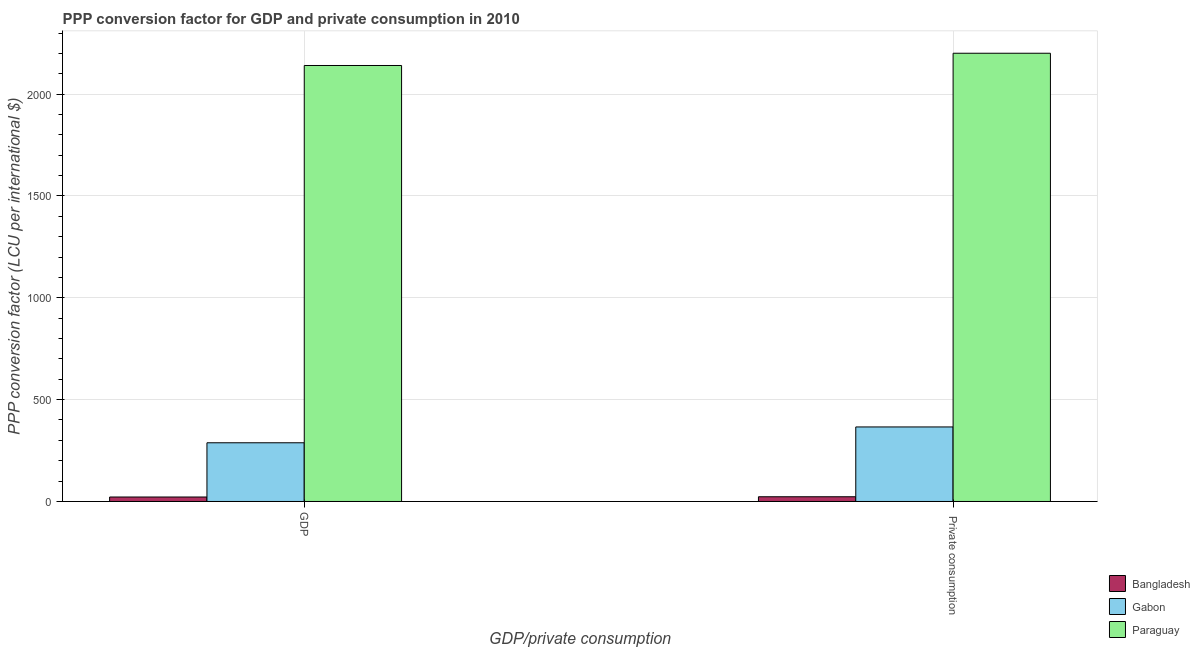How many different coloured bars are there?
Offer a terse response. 3. Are the number of bars on each tick of the X-axis equal?
Offer a terse response. Yes. How many bars are there on the 2nd tick from the left?
Give a very brief answer. 3. What is the label of the 2nd group of bars from the left?
Your answer should be compact.  Private consumption. What is the ppp conversion factor for private consumption in Bangladesh?
Make the answer very short. 23.15. Across all countries, what is the maximum ppp conversion factor for private consumption?
Give a very brief answer. 2200.69. Across all countries, what is the minimum ppp conversion factor for gdp?
Your answer should be compact. 21.9. In which country was the ppp conversion factor for private consumption maximum?
Offer a terse response. Paraguay. What is the total ppp conversion factor for gdp in the graph?
Provide a short and direct response. 2450.59. What is the difference between the ppp conversion factor for private consumption in Gabon and that in Bangladesh?
Keep it short and to the point. 342.76. What is the difference between the ppp conversion factor for gdp in Bangladesh and the ppp conversion factor for private consumption in Paraguay?
Give a very brief answer. -2178.79. What is the average ppp conversion factor for gdp per country?
Give a very brief answer. 816.86. What is the difference between the ppp conversion factor for private consumption and ppp conversion factor for gdp in Gabon?
Offer a very short reply. 77.73. What is the ratio of the ppp conversion factor for private consumption in Gabon to that in Paraguay?
Your response must be concise. 0.17. Is the ppp conversion factor for private consumption in Gabon less than that in Paraguay?
Provide a succinct answer. Yes. What does the 2nd bar from the left in  Private consumption represents?
Provide a short and direct response. Gabon. What does the 1st bar from the right in GDP represents?
Make the answer very short. Paraguay. How many countries are there in the graph?
Your answer should be very brief. 3. What is the difference between two consecutive major ticks on the Y-axis?
Your answer should be compact. 500. Does the graph contain grids?
Keep it short and to the point. Yes. Where does the legend appear in the graph?
Make the answer very short. Bottom right. How many legend labels are there?
Your answer should be very brief. 3. How are the legend labels stacked?
Offer a very short reply. Vertical. What is the title of the graph?
Your answer should be compact. PPP conversion factor for GDP and private consumption in 2010. Does "Albania" appear as one of the legend labels in the graph?
Offer a terse response. No. What is the label or title of the X-axis?
Offer a terse response. GDP/private consumption. What is the label or title of the Y-axis?
Ensure brevity in your answer.  PPP conversion factor (LCU per international $). What is the PPP conversion factor (LCU per international $) of Bangladesh in GDP?
Your answer should be compact. 21.9. What is the PPP conversion factor (LCU per international $) of Gabon in GDP?
Offer a terse response. 288.18. What is the PPP conversion factor (LCU per international $) in Paraguay in GDP?
Make the answer very short. 2140.51. What is the PPP conversion factor (LCU per international $) of Bangladesh in  Private consumption?
Make the answer very short. 23.15. What is the PPP conversion factor (LCU per international $) in Gabon in  Private consumption?
Ensure brevity in your answer.  365.91. What is the PPP conversion factor (LCU per international $) in Paraguay in  Private consumption?
Give a very brief answer. 2200.69. Across all GDP/private consumption, what is the maximum PPP conversion factor (LCU per international $) of Bangladesh?
Your answer should be compact. 23.15. Across all GDP/private consumption, what is the maximum PPP conversion factor (LCU per international $) in Gabon?
Give a very brief answer. 365.91. Across all GDP/private consumption, what is the maximum PPP conversion factor (LCU per international $) in Paraguay?
Keep it short and to the point. 2200.69. Across all GDP/private consumption, what is the minimum PPP conversion factor (LCU per international $) in Bangladesh?
Provide a short and direct response. 21.9. Across all GDP/private consumption, what is the minimum PPP conversion factor (LCU per international $) of Gabon?
Your response must be concise. 288.18. Across all GDP/private consumption, what is the minimum PPP conversion factor (LCU per international $) of Paraguay?
Offer a very short reply. 2140.51. What is the total PPP conversion factor (LCU per international $) of Bangladesh in the graph?
Provide a short and direct response. 45.06. What is the total PPP conversion factor (LCU per international $) of Gabon in the graph?
Provide a succinct answer. 654.09. What is the total PPP conversion factor (LCU per international $) in Paraguay in the graph?
Provide a short and direct response. 4341.2. What is the difference between the PPP conversion factor (LCU per international $) of Bangladesh in GDP and that in  Private consumption?
Offer a terse response. -1.25. What is the difference between the PPP conversion factor (LCU per international $) in Gabon in GDP and that in  Private consumption?
Provide a short and direct response. -77.73. What is the difference between the PPP conversion factor (LCU per international $) in Paraguay in GDP and that in  Private consumption?
Provide a succinct answer. -60.18. What is the difference between the PPP conversion factor (LCU per international $) in Bangladesh in GDP and the PPP conversion factor (LCU per international $) in Gabon in  Private consumption?
Provide a short and direct response. -344.01. What is the difference between the PPP conversion factor (LCU per international $) in Bangladesh in GDP and the PPP conversion factor (LCU per international $) in Paraguay in  Private consumption?
Provide a short and direct response. -2178.79. What is the difference between the PPP conversion factor (LCU per international $) in Gabon in GDP and the PPP conversion factor (LCU per international $) in Paraguay in  Private consumption?
Give a very brief answer. -1912.51. What is the average PPP conversion factor (LCU per international $) in Bangladesh per GDP/private consumption?
Keep it short and to the point. 22.53. What is the average PPP conversion factor (LCU per international $) in Gabon per GDP/private consumption?
Offer a terse response. 327.05. What is the average PPP conversion factor (LCU per international $) of Paraguay per GDP/private consumption?
Offer a very short reply. 2170.6. What is the difference between the PPP conversion factor (LCU per international $) in Bangladesh and PPP conversion factor (LCU per international $) in Gabon in GDP?
Provide a short and direct response. -266.28. What is the difference between the PPP conversion factor (LCU per international $) of Bangladesh and PPP conversion factor (LCU per international $) of Paraguay in GDP?
Offer a terse response. -2118.61. What is the difference between the PPP conversion factor (LCU per international $) in Gabon and PPP conversion factor (LCU per international $) in Paraguay in GDP?
Keep it short and to the point. -1852.33. What is the difference between the PPP conversion factor (LCU per international $) in Bangladesh and PPP conversion factor (LCU per international $) in Gabon in  Private consumption?
Give a very brief answer. -342.76. What is the difference between the PPP conversion factor (LCU per international $) in Bangladesh and PPP conversion factor (LCU per international $) in Paraguay in  Private consumption?
Give a very brief answer. -2177.54. What is the difference between the PPP conversion factor (LCU per international $) in Gabon and PPP conversion factor (LCU per international $) in Paraguay in  Private consumption?
Make the answer very short. -1834.78. What is the ratio of the PPP conversion factor (LCU per international $) in Bangladesh in GDP to that in  Private consumption?
Offer a terse response. 0.95. What is the ratio of the PPP conversion factor (LCU per international $) of Gabon in GDP to that in  Private consumption?
Your response must be concise. 0.79. What is the ratio of the PPP conversion factor (LCU per international $) of Paraguay in GDP to that in  Private consumption?
Provide a succinct answer. 0.97. What is the difference between the highest and the second highest PPP conversion factor (LCU per international $) of Bangladesh?
Your answer should be compact. 1.25. What is the difference between the highest and the second highest PPP conversion factor (LCU per international $) of Gabon?
Your answer should be very brief. 77.73. What is the difference between the highest and the second highest PPP conversion factor (LCU per international $) of Paraguay?
Make the answer very short. 60.18. What is the difference between the highest and the lowest PPP conversion factor (LCU per international $) of Bangladesh?
Your answer should be compact. 1.25. What is the difference between the highest and the lowest PPP conversion factor (LCU per international $) of Gabon?
Offer a terse response. 77.73. What is the difference between the highest and the lowest PPP conversion factor (LCU per international $) of Paraguay?
Your response must be concise. 60.18. 